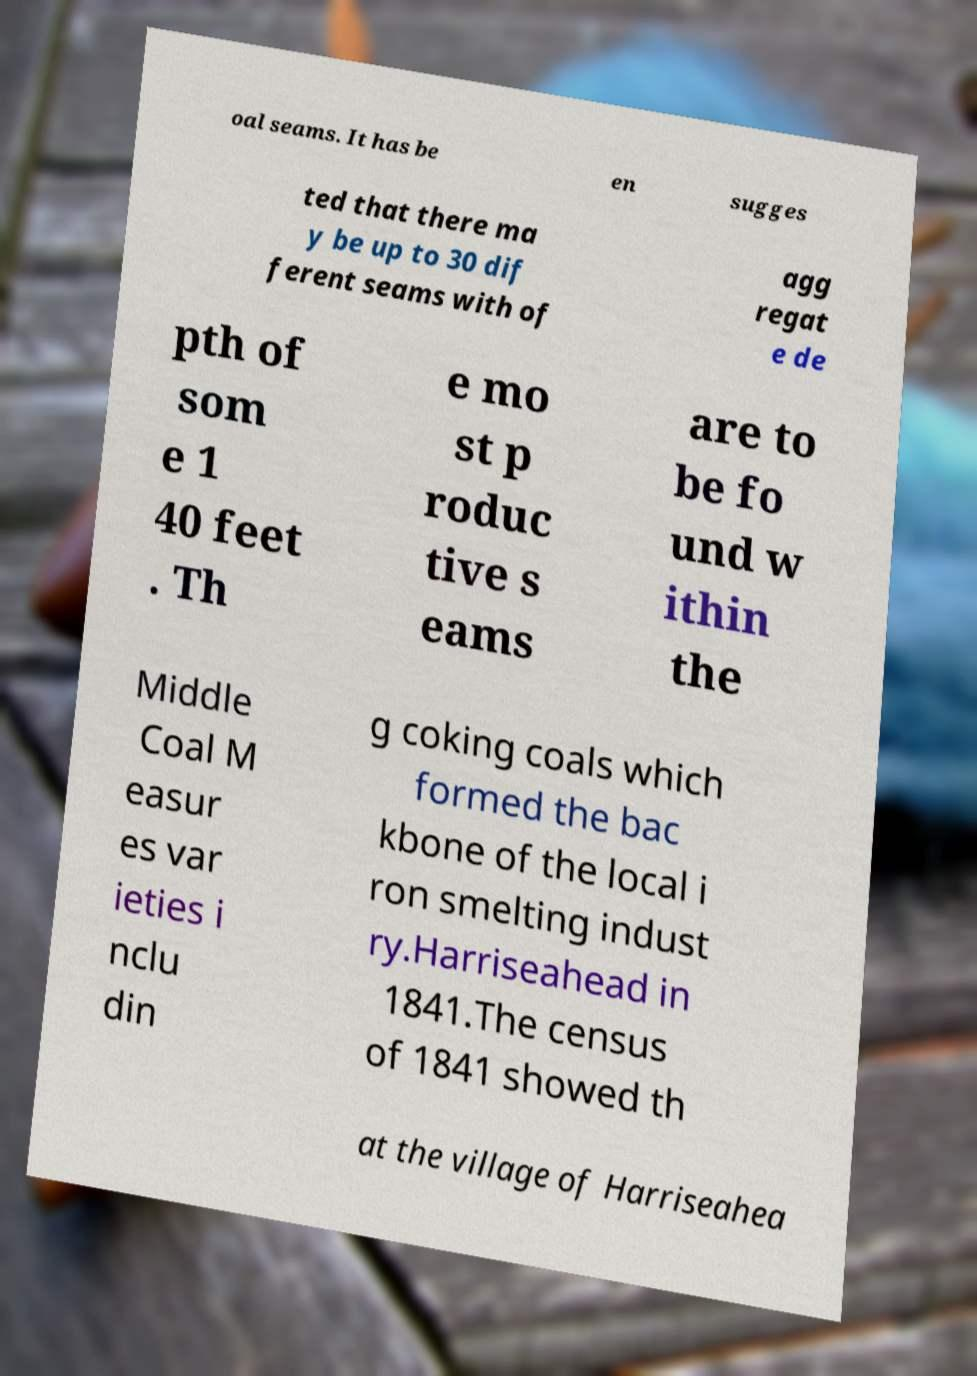For documentation purposes, I need the text within this image transcribed. Could you provide that? oal seams. It has be en sugges ted that there ma y be up to 30 dif ferent seams with of agg regat e de pth of som e 1 40 feet . Th e mo st p roduc tive s eams are to be fo und w ithin the Middle Coal M easur es var ieties i nclu din g coking coals which formed the bac kbone of the local i ron smelting indust ry.Harriseahead in 1841.The census of 1841 showed th at the village of Harriseahea 